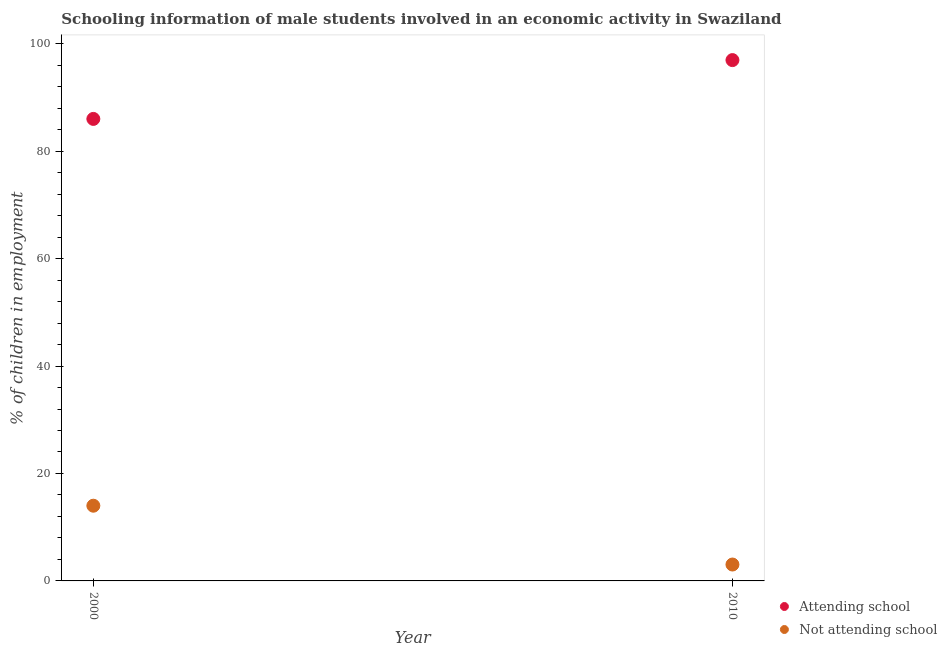Is the number of dotlines equal to the number of legend labels?
Keep it short and to the point. Yes. What is the percentage of employed males who are attending school in 2000?
Keep it short and to the point. 86. Across all years, what is the maximum percentage of employed males who are attending school?
Offer a very short reply. 96.95. Across all years, what is the minimum percentage of employed males who are attending school?
Offer a very short reply. 86. In which year was the percentage of employed males who are attending school maximum?
Your answer should be compact. 2010. What is the total percentage of employed males who are attending school in the graph?
Your response must be concise. 182.95. What is the difference between the percentage of employed males who are attending school in 2000 and that in 2010?
Keep it short and to the point. -10.95. What is the difference between the percentage of employed males who are attending school in 2010 and the percentage of employed males who are not attending school in 2000?
Make the answer very short. 82.95. What is the average percentage of employed males who are not attending school per year?
Offer a terse response. 8.53. In the year 2000, what is the difference between the percentage of employed males who are attending school and percentage of employed males who are not attending school?
Provide a succinct answer. 72. What is the ratio of the percentage of employed males who are attending school in 2000 to that in 2010?
Your response must be concise. 0.89. In how many years, is the percentage of employed males who are attending school greater than the average percentage of employed males who are attending school taken over all years?
Offer a terse response. 1. Does the percentage of employed males who are not attending school monotonically increase over the years?
Provide a short and direct response. No. How many dotlines are there?
Offer a very short reply. 2. Are the values on the major ticks of Y-axis written in scientific E-notation?
Your response must be concise. No. Does the graph contain grids?
Provide a succinct answer. No. Where does the legend appear in the graph?
Your answer should be compact. Bottom right. How many legend labels are there?
Provide a short and direct response. 2. How are the legend labels stacked?
Keep it short and to the point. Vertical. What is the title of the graph?
Make the answer very short. Schooling information of male students involved in an economic activity in Swaziland. Does "Excluding technical cooperation" appear as one of the legend labels in the graph?
Your answer should be very brief. No. What is the label or title of the Y-axis?
Your response must be concise. % of children in employment. What is the % of children in employment in Attending school in 2000?
Your answer should be compact. 86. What is the % of children in employment of Not attending school in 2000?
Your answer should be very brief. 14. What is the % of children in employment in Attending school in 2010?
Keep it short and to the point. 96.95. What is the % of children in employment of Not attending school in 2010?
Give a very brief answer. 3.05. Across all years, what is the maximum % of children in employment in Attending school?
Offer a very short reply. 96.95. Across all years, what is the minimum % of children in employment of Attending school?
Make the answer very short. 86. Across all years, what is the minimum % of children in employment of Not attending school?
Make the answer very short. 3.05. What is the total % of children in employment of Attending school in the graph?
Your response must be concise. 182.95. What is the total % of children in employment of Not attending school in the graph?
Provide a succinct answer. 17.05. What is the difference between the % of children in employment of Attending school in 2000 and that in 2010?
Offer a terse response. -10.95. What is the difference between the % of children in employment of Not attending school in 2000 and that in 2010?
Provide a short and direct response. 10.95. What is the difference between the % of children in employment of Attending school in 2000 and the % of children in employment of Not attending school in 2010?
Provide a short and direct response. 82.95. What is the average % of children in employment in Attending school per year?
Make the answer very short. 91.47. What is the average % of children in employment of Not attending school per year?
Make the answer very short. 8.53. In the year 2000, what is the difference between the % of children in employment of Attending school and % of children in employment of Not attending school?
Your answer should be very brief. 72. In the year 2010, what is the difference between the % of children in employment of Attending school and % of children in employment of Not attending school?
Your answer should be compact. 93.9. What is the ratio of the % of children in employment in Attending school in 2000 to that in 2010?
Give a very brief answer. 0.89. What is the ratio of the % of children in employment of Not attending school in 2000 to that in 2010?
Offer a very short reply. 4.59. What is the difference between the highest and the second highest % of children in employment in Attending school?
Give a very brief answer. 10.95. What is the difference between the highest and the second highest % of children in employment of Not attending school?
Give a very brief answer. 10.95. What is the difference between the highest and the lowest % of children in employment in Attending school?
Make the answer very short. 10.95. What is the difference between the highest and the lowest % of children in employment in Not attending school?
Provide a succinct answer. 10.95. 